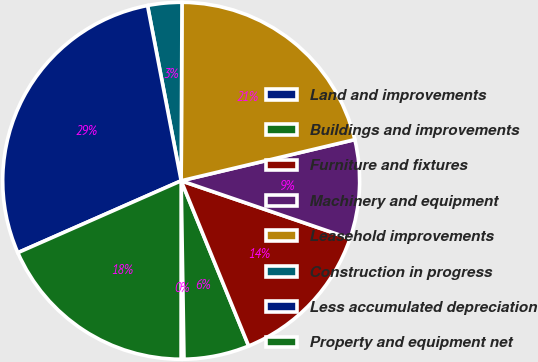<chart> <loc_0><loc_0><loc_500><loc_500><pie_chart><fcel>Land and improvements<fcel>Buildings and improvements<fcel>Furniture and fixtures<fcel>Machinery and equipment<fcel>Leasehold improvements<fcel>Construction in progress<fcel>Less accumulated depreciation<fcel>Property and equipment net<nl><fcel>0.26%<fcel>5.92%<fcel>13.58%<fcel>8.95%<fcel>21.22%<fcel>3.09%<fcel>28.58%<fcel>18.39%<nl></chart> 